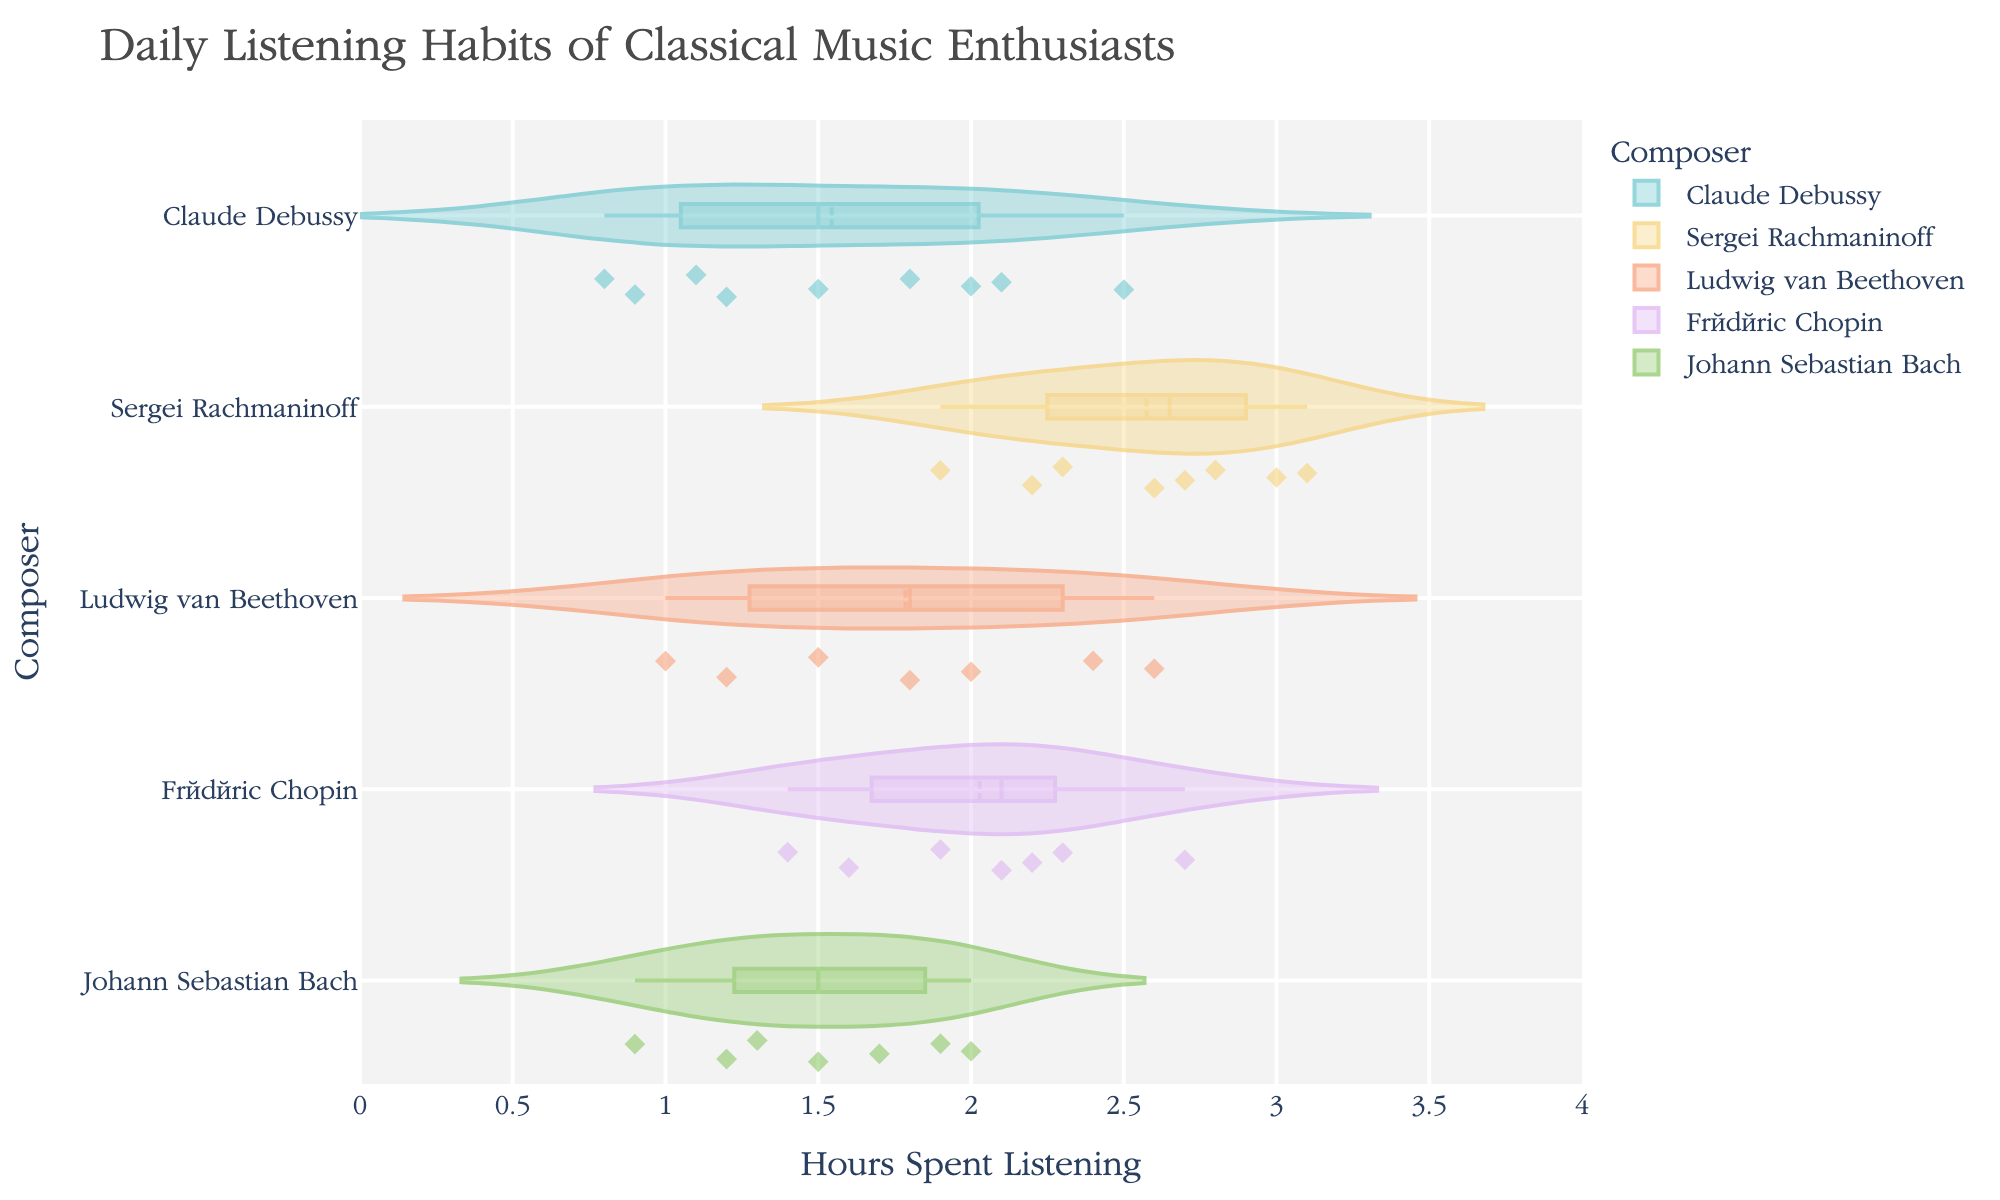What is the title of the figure? Look at the top of the figure to read the title directly.
Answer: Daily Listening Habits of Classical Music Enthusiasts Which composer has the widest spread of daily listening hours? Observe the width of the violin plots; the widest spread indicates the most variance in listening hours.
Answer: Sergei Rachmaninoff What is the median daily listening time for Claude Debussy? Check the violin plot for Claude Debussy and locate the median line within the box plot overlay.
Answer: 1.5 hours Which composer has the highest average daily listening hours? Identify the center of the distribution curves for each violin plot. Compare their means indicated by the mean lines.
Answer: Sergei Rachmaninoff How do the distributions of daily listening hours for Beethoven and Bach compare? Compare the shapes and spreads of the violin plots for both composers to analyze differences in distribution.
Answer: Beethoven has a wider range, while Bach's listening hours are more centrally distributed What is the interquartile range (IQR) for Frédéric Chopin? The IQR is represented by the height of the box plot within the violin plot. Subtract the lower quartile from the upper quartile.
Answer: 0.9 hours Which composer shows the most consistent listening habits? Consistency can be inferred from the least spread in the violin plot. Look for the narrowest violin plot.
Answer: Johann Sebastian Bach How many data points are there for Sergei Rachmaninoff? Count the number of individual points within Sergei Rachmaninoff's violin plot.
Answer: 8 data points How do the median listening times for Debussy and Rachmaninoff differ? Identify the median lines in the box plots for both composers and calculate the difference between them.
Answer: Rachmaninoff's median is higher by approximately 1.0 hours What is the shape of the distribution for Johann Sebastian Bach's listening hours? Observe and describe the overall shape of the violin plot; whether it is symmetric, skewed, peaked, etc.
Answer: The distribution is relatively symmetric and peaked around the center 